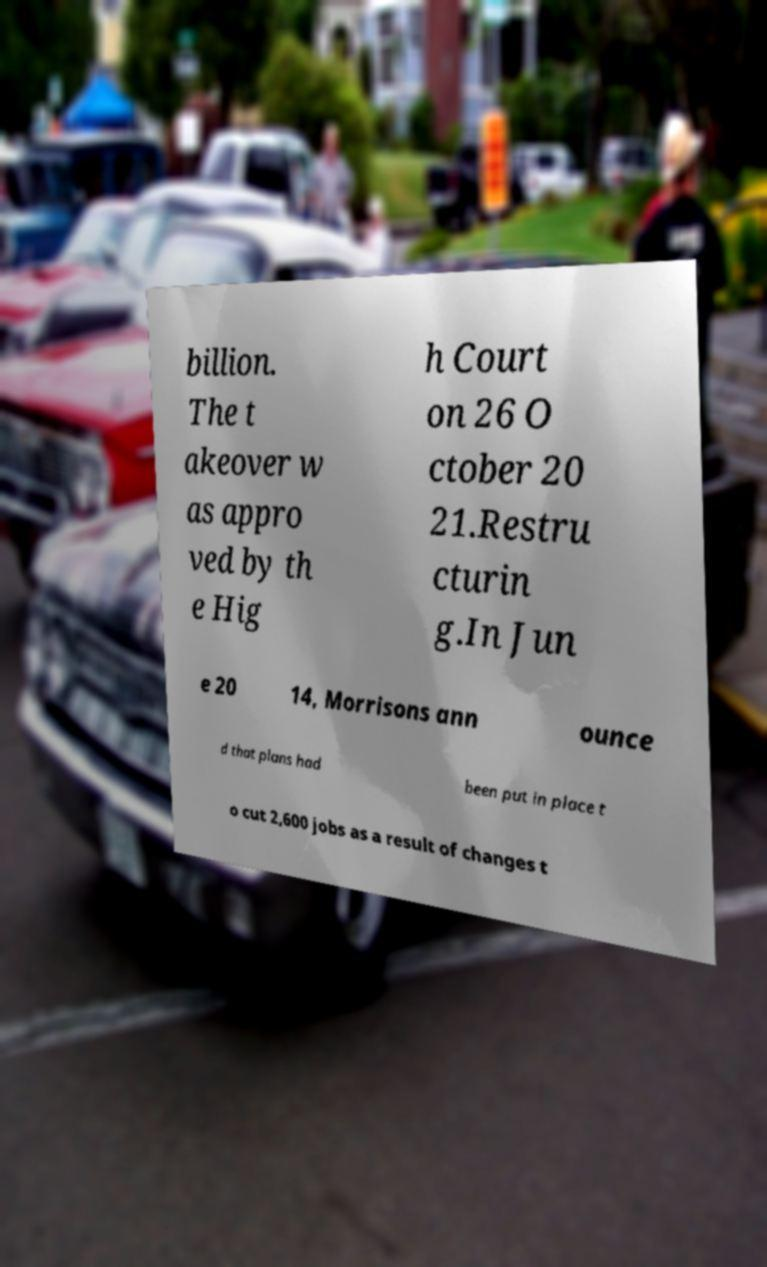What messages or text are displayed in this image? I need them in a readable, typed format. billion. The t akeover w as appro ved by th e Hig h Court on 26 O ctober 20 21.Restru cturin g.In Jun e 20 14, Morrisons ann ounce d that plans had been put in place t o cut 2,600 jobs as a result of changes t 